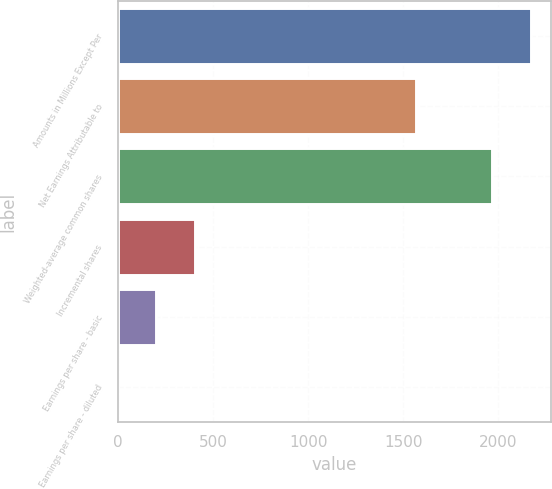Convert chart. <chart><loc_0><loc_0><loc_500><loc_500><bar_chart><fcel>Amounts in Millions Except Per<fcel>Net Earnings Attributable to<fcel>Weighted-average common shares<fcel>Incremental shares<fcel>Earnings per share - basic<fcel>Earnings per share - diluted<nl><fcel>2169.23<fcel>1565<fcel>1967.82<fcel>403.75<fcel>202.34<fcel>0.93<nl></chart> 